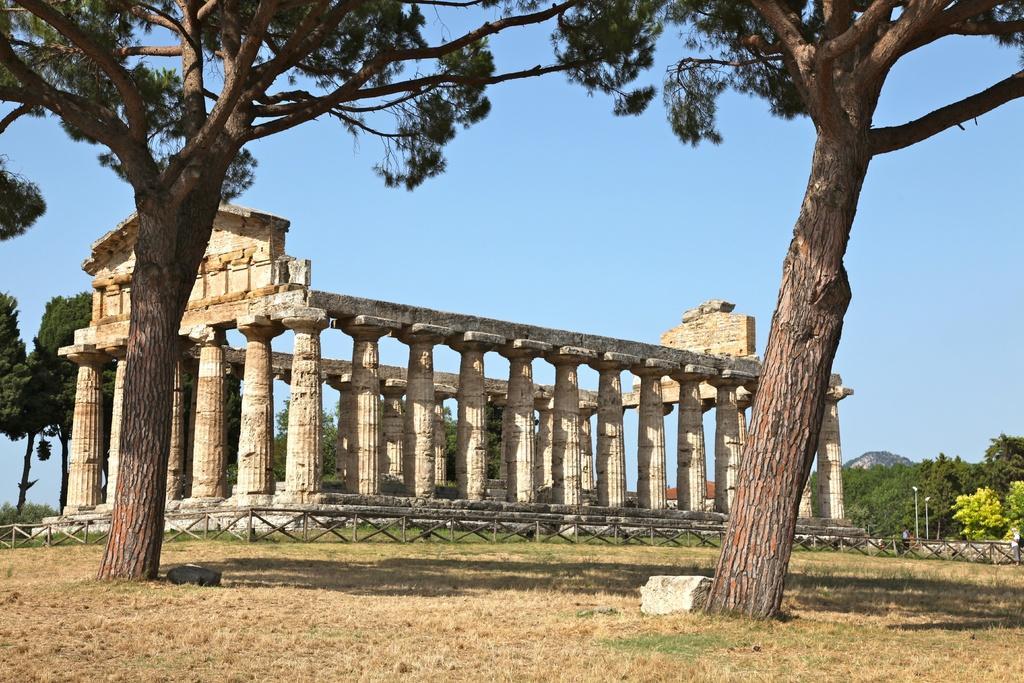Describe this image in one or two sentences. In this picture there is a temple of Athena and there is a tree on either sides of it and there are few other trees in the background. 